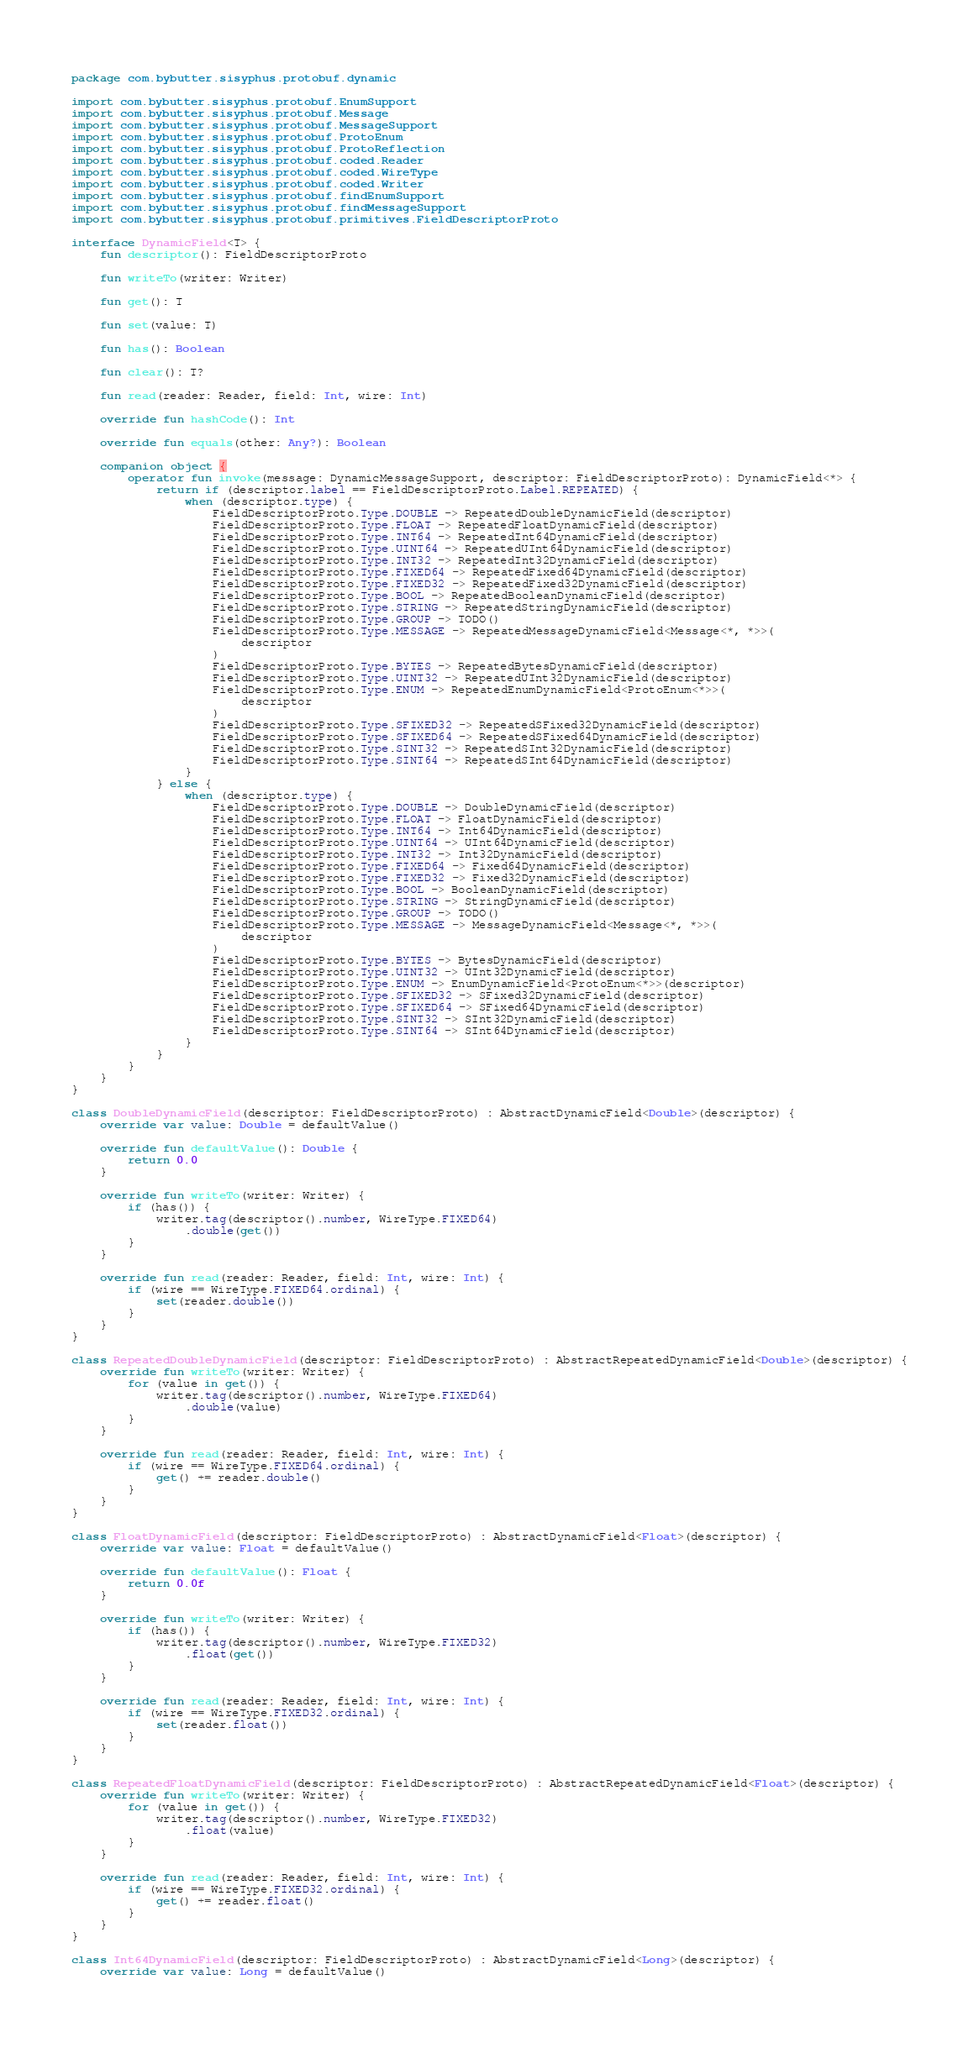<code> <loc_0><loc_0><loc_500><loc_500><_Kotlin_>package com.bybutter.sisyphus.protobuf.dynamic

import com.bybutter.sisyphus.protobuf.EnumSupport
import com.bybutter.sisyphus.protobuf.Message
import com.bybutter.sisyphus.protobuf.MessageSupport
import com.bybutter.sisyphus.protobuf.ProtoEnum
import com.bybutter.sisyphus.protobuf.ProtoReflection
import com.bybutter.sisyphus.protobuf.coded.Reader
import com.bybutter.sisyphus.protobuf.coded.WireType
import com.bybutter.sisyphus.protobuf.coded.Writer
import com.bybutter.sisyphus.protobuf.findEnumSupport
import com.bybutter.sisyphus.protobuf.findMessageSupport
import com.bybutter.sisyphus.protobuf.primitives.FieldDescriptorProto

interface DynamicField<T> {
    fun descriptor(): FieldDescriptorProto

    fun writeTo(writer: Writer)

    fun get(): T

    fun set(value: T)

    fun has(): Boolean

    fun clear(): T?

    fun read(reader: Reader, field: Int, wire: Int)

    override fun hashCode(): Int

    override fun equals(other: Any?): Boolean

    companion object {
        operator fun invoke(message: DynamicMessageSupport, descriptor: FieldDescriptorProto): DynamicField<*> {
            return if (descriptor.label == FieldDescriptorProto.Label.REPEATED) {
                when (descriptor.type) {
                    FieldDescriptorProto.Type.DOUBLE -> RepeatedDoubleDynamicField(descriptor)
                    FieldDescriptorProto.Type.FLOAT -> RepeatedFloatDynamicField(descriptor)
                    FieldDescriptorProto.Type.INT64 -> RepeatedInt64DynamicField(descriptor)
                    FieldDescriptorProto.Type.UINT64 -> RepeatedUInt64DynamicField(descriptor)
                    FieldDescriptorProto.Type.INT32 -> RepeatedInt32DynamicField(descriptor)
                    FieldDescriptorProto.Type.FIXED64 -> RepeatedFixed64DynamicField(descriptor)
                    FieldDescriptorProto.Type.FIXED32 -> RepeatedFixed32DynamicField(descriptor)
                    FieldDescriptorProto.Type.BOOL -> RepeatedBooleanDynamicField(descriptor)
                    FieldDescriptorProto.Type.STRING -> RepeatedStringDynamicField(descriptor)
                    FieldDescriptorProto.Type.GROUP -> TODO()
                    FieldDescriptorProto.Type.MESSAGE -> RepeatedMessageDynamicField<Message<*, *>>(
                        descriptor
                    )
                    FieldDescriptorProto.Type.BYTES -> RepeatedBytesDynamicField(descriptor)
                    FieldDescriptorProto.Type.UINT32 -> RepeatedUInt32DynamicField(descriptor)
                    FieldDescriptorProto.Type.ENUM -> RepeatedEnumDynamicField<ProtoEnum<*>>(
                        descriptor
                    )
                    FieldDescriptorProto.Type.SFIXED32 -> RepeatedSFixed32DynamicField(descriptor)
                    FieldDescriptorProto.Type.SFIXED64 -> RepeatedSFixed64DynamicField(descriptor)
                    FieldDescriptorProto.Type.SINT32 -> RepeatedSInt32DynamicField(descriptor)
                    FieldDescriptorProto.Type.SINT64 -> RepeatedSInt64DynamicField(descriptor)
                }
            } else {
                when (descriptor.type) {
                    FieldDescriptorProto.Type.DOUBLE -> DoubleDynamicField(descriptor)
                    FieldDescriptorProto.Type.FLOAT -> FloatDynamicField(descriptor)
                    FieldDescriptorProto.Type.INT64 -> Int64DynamicField(descriptor)
                    FieldDescriptorProto.Type.UINT64 -> UInt64DynamicField(descriptor)
                    FieldDescriptorProto.Type.INT32 -> Int32DynamicField(descriptor)
                    FieldDescriptorProto.Type.FIXED64 -> Fixed64DynamicField(descriptor)
                    FieldDescriptorProto.Type.FIXED32 -> Fixed32DynamicField(descriptor)
                    FieldDescriptorProto.Type.BOOL -> BooleanDynamicField(descriptor)
                    FieldDescriptorProto.Type.STRING -> StringDynamicField(descriptor)
                    FieldDescriptorProto.Type.GROUP -> TODO()
                    FieldDescriptorProto.Type.MESSAGE -> MessageDynamicField<Message<*, *>>(
                        descriptor
                    )
                    FieldDescriptorProto.Type.BYTES -> BytesDynamicField(descriptor)
                    FieldDescriptorProto.Type.UINT32 -> UInt32DynamicField(descriptor)
                    FieldDescriptorProto.Type.ENUM -> EnumDynamicField<ProtoEnum<*>>(descriptor)
                    FieldDescriptorProto.Type.SFIXED32 -> SFixed32DynamicField(descriptor)
                    FieldDescriptorProto.Type.SFIXED64 -> SFixed64DynamicField(descriptor)
                    FieldDescriptorProto.Type.SINT32 -> SInt32DynamicField(descriptor)
                    FieldDescriptorProto.Type.SINT64 -> SInt64DynamicField(descriptor)
                }
            }
        }
    }
}

class DoubleDynamicField(descriptor: FieldDescriptorProto) : AbstractDynamicField<Double>(descriptor) {
    override var value: Double = defaultValue()

    override fun defaultValue(): Double {
        return 0.0
    }

    override fun writeTo(writer: Writer) {
        if (has()) {
            writer.tag(descriptor().number, WireType.FIXED64)
                .double(get())
        }
    }

    override fun read(reader: Reader, field: Int, wire: Int) {
        if (wire == WireType.FIXED64.ordinal) {
            set(reader.double())
        }
    }
}

class RepeatedDoubleDynamicField(descriptor: FieldDescriptorProto) : AbstractRepeatedDynamicField<Double>(descriptor) {
    override fun writeTo(writer: Writer) {
        for (value in get()) {
            writer.tag(descriptor().number, WireType.FIXED64)
                .double(value)
        }
    }

    override fun read(reader: Reader, field: Int, wire: Int) {
        if (wire == WireType.FIXED64.ordinal) {
            get() += reader.double()
        }
    }
}

class FloatDynamicField(descriptor: FieldDescriptorProto) : AbstractDynamicField<Float>(descriptor) {
    override var value: Float = defaultValue()

    override fun defaultValue(): Float {
        return 0.0f
    }

    override fun writeTo(writer: Writer) {
        if (has()) {
            writer.tag(descriptor().number, WireType.FIXED32)
                .float(get())
        }
    }

    override fun read(reader: Reader, field: Int, wire: Int) {
        if (wire == WireType.FIXED32.ordinal) {
            set(reader.float())
        }
    }
}

class RepeatedFloatDynamicField(descriptor: FieldDescriptorProto) : AbstractRepeatedDynamicField<Float>(descriptor) {
    override fun writeTo(writer: Writer) {
        for (value in get()) {
            writer.tag(descriptor().number, WireType.FIXED32)
                .float(value)
        }
    }

    override fun read(reader: Reader, field: Int, wire: Int) {
        if (wire == WireType.FIXED32.ordinal) {
            get() += reader.float()
        }
    }
}

class Int64DynamicField(descriptor: FieldDescriptorProto) : AbstractDynamicField<Long>(descriptor) {
    override var value: Long = defaultValue()
</code> 